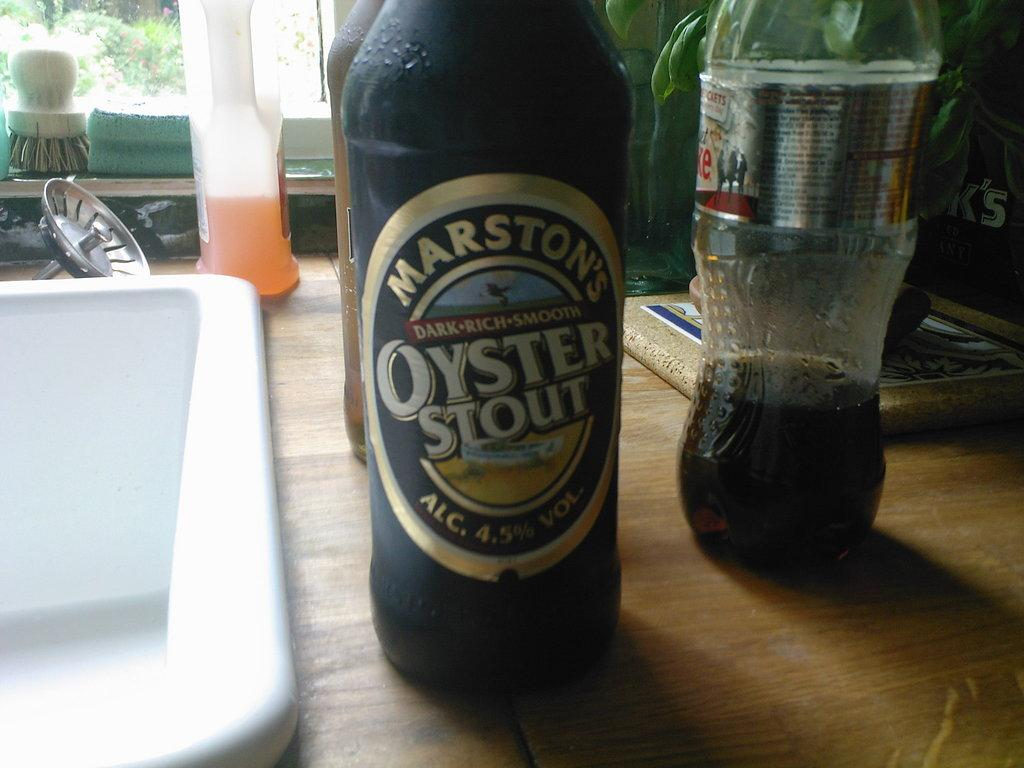<image>
Write a terse but informative summary of the picture. A Marston's Dark Rich Smooth Oyster Stout beer bottle is next to a kitchen sink. 